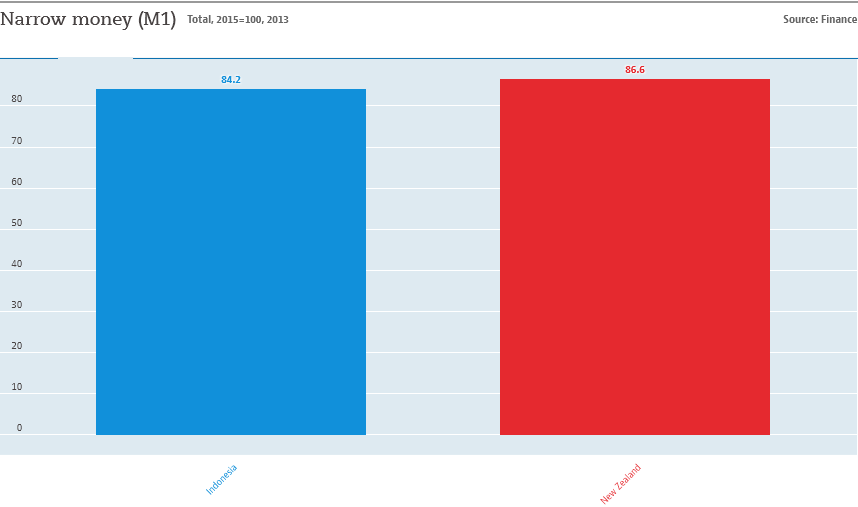Highlight a few significant elements in this photo. The average of red and blue bars is 85.4. The country represented by the red bar is New Zealand. 